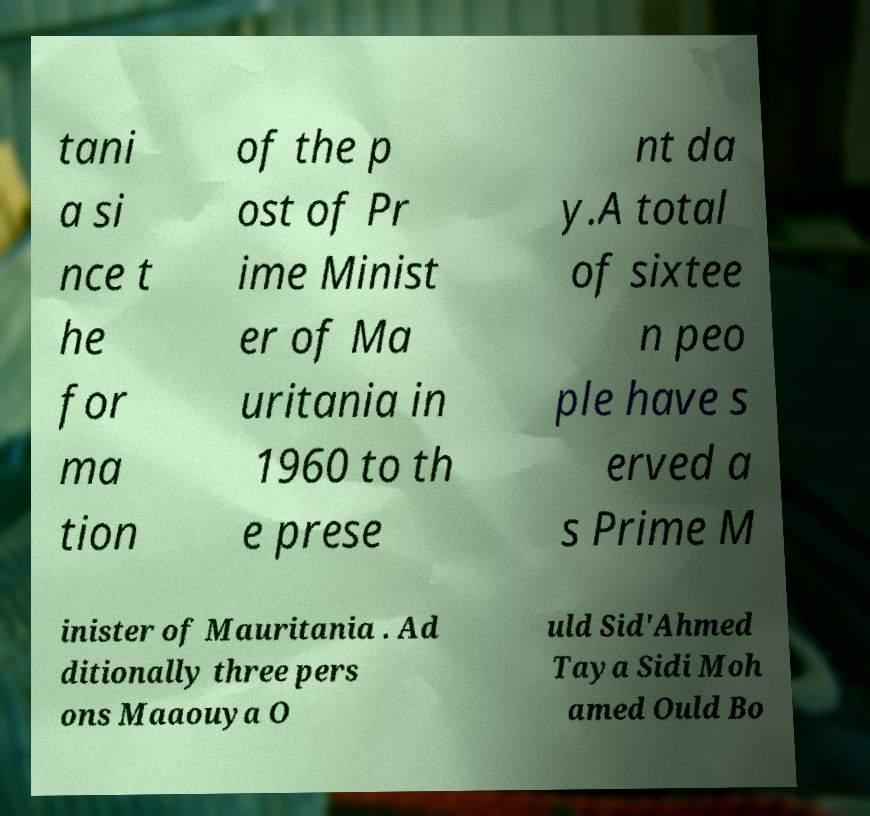Can you accurately transcribe the text from the provided image for me? tani a si nce t he for ma tion of the p ost of Pr ime Minist er of Ma uritania in 1960 to th e prese nt da y.A total of sixtee n peo ple have s erved a s Prime M inister of Mauritania . Ad ditionally three pers ons Maaouya O uld Sid'Ahmed Taya Sidi Moh amed Ould Bo 